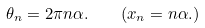<formula> <loc_0><loc_0><loc_500><loc_500>\theta _ { n } = 2 \pi n \alpha . \quad ( x _ { n } = n \alpha . )</formula> 